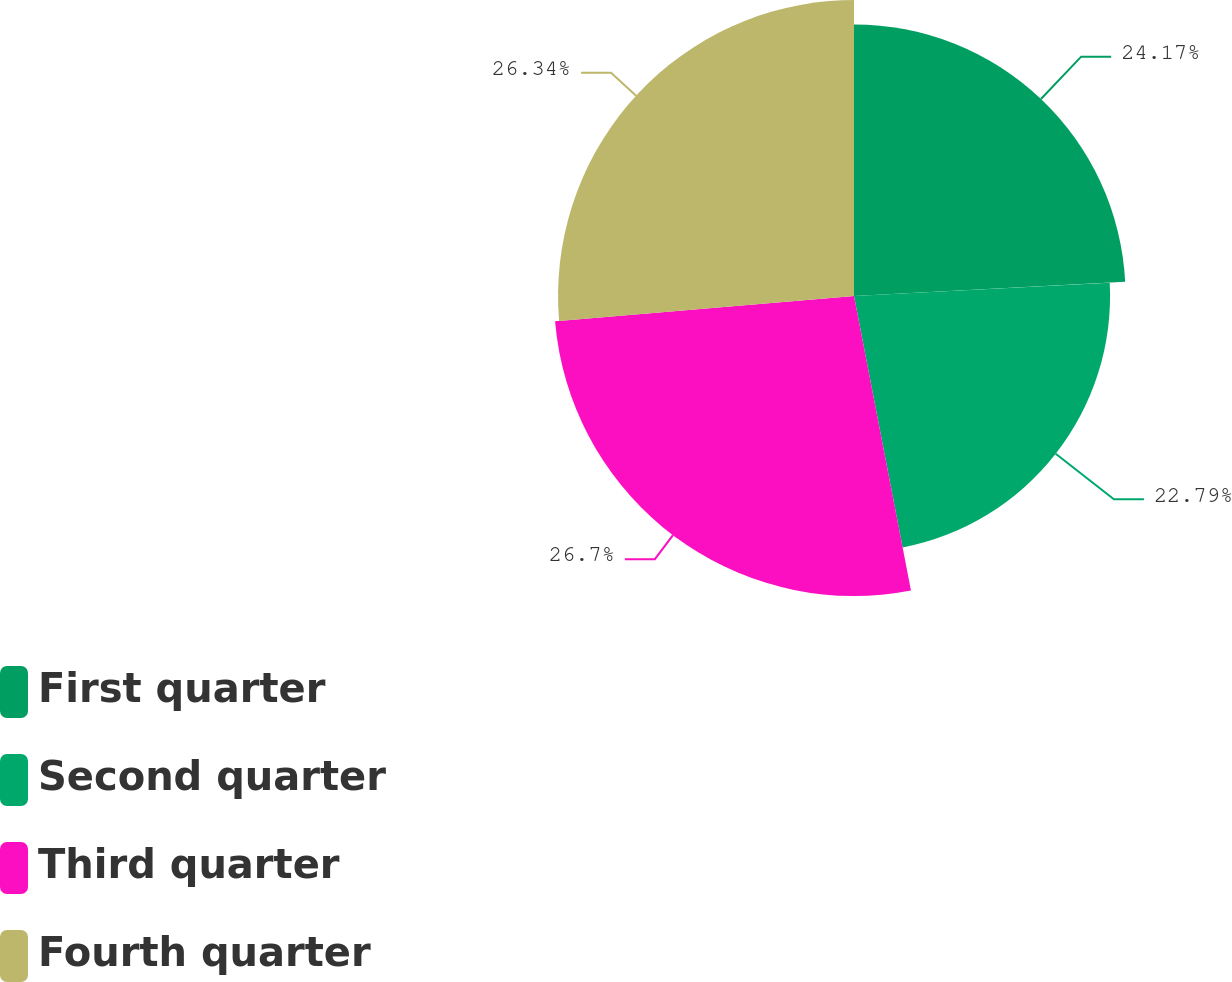<chart> <loc_0><loc_0><loc_500><loc_500><pie_chart><fcel>First quarter<fcel>Second quarter<fcel>Third quarter<fcel>Fourth quarter<nl><fcel>24.17%<fcel>22.79%<fcel>26.7%<fcel>26.34%<nl></chart> 